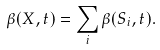Convert formula to latex. <formula><loc_0><loc_0><loc_500><loc_500>\beta ( X , t ) = \sum _ { i } \beta ( S _ { i } , t ) .</formula> 